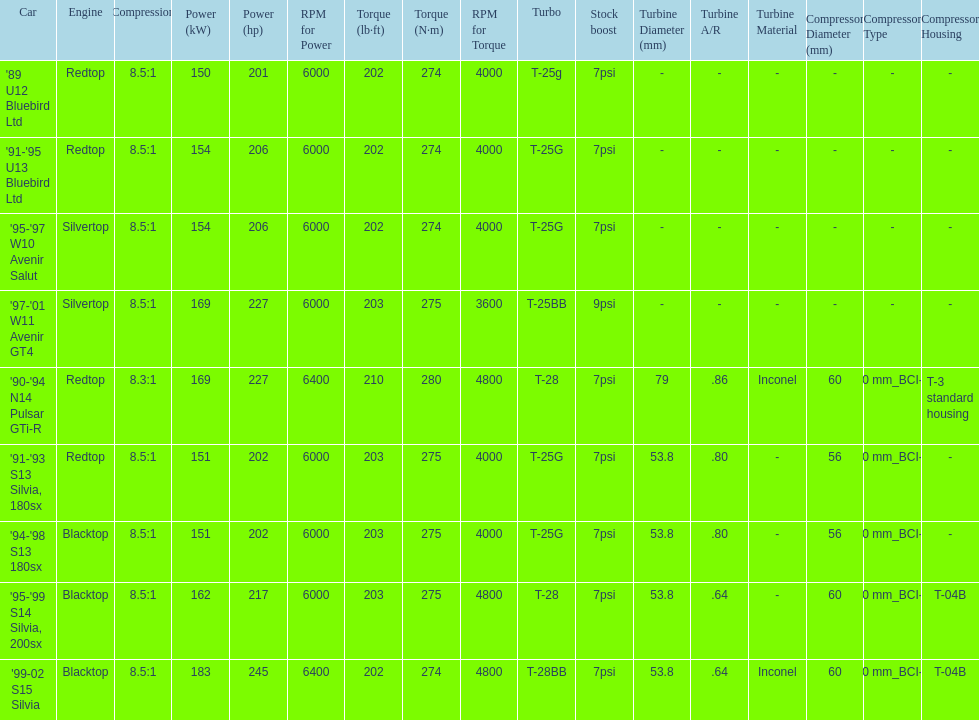Which car has a stock boost of over 7psi? '97-'01 W11 Avenir GT4. 